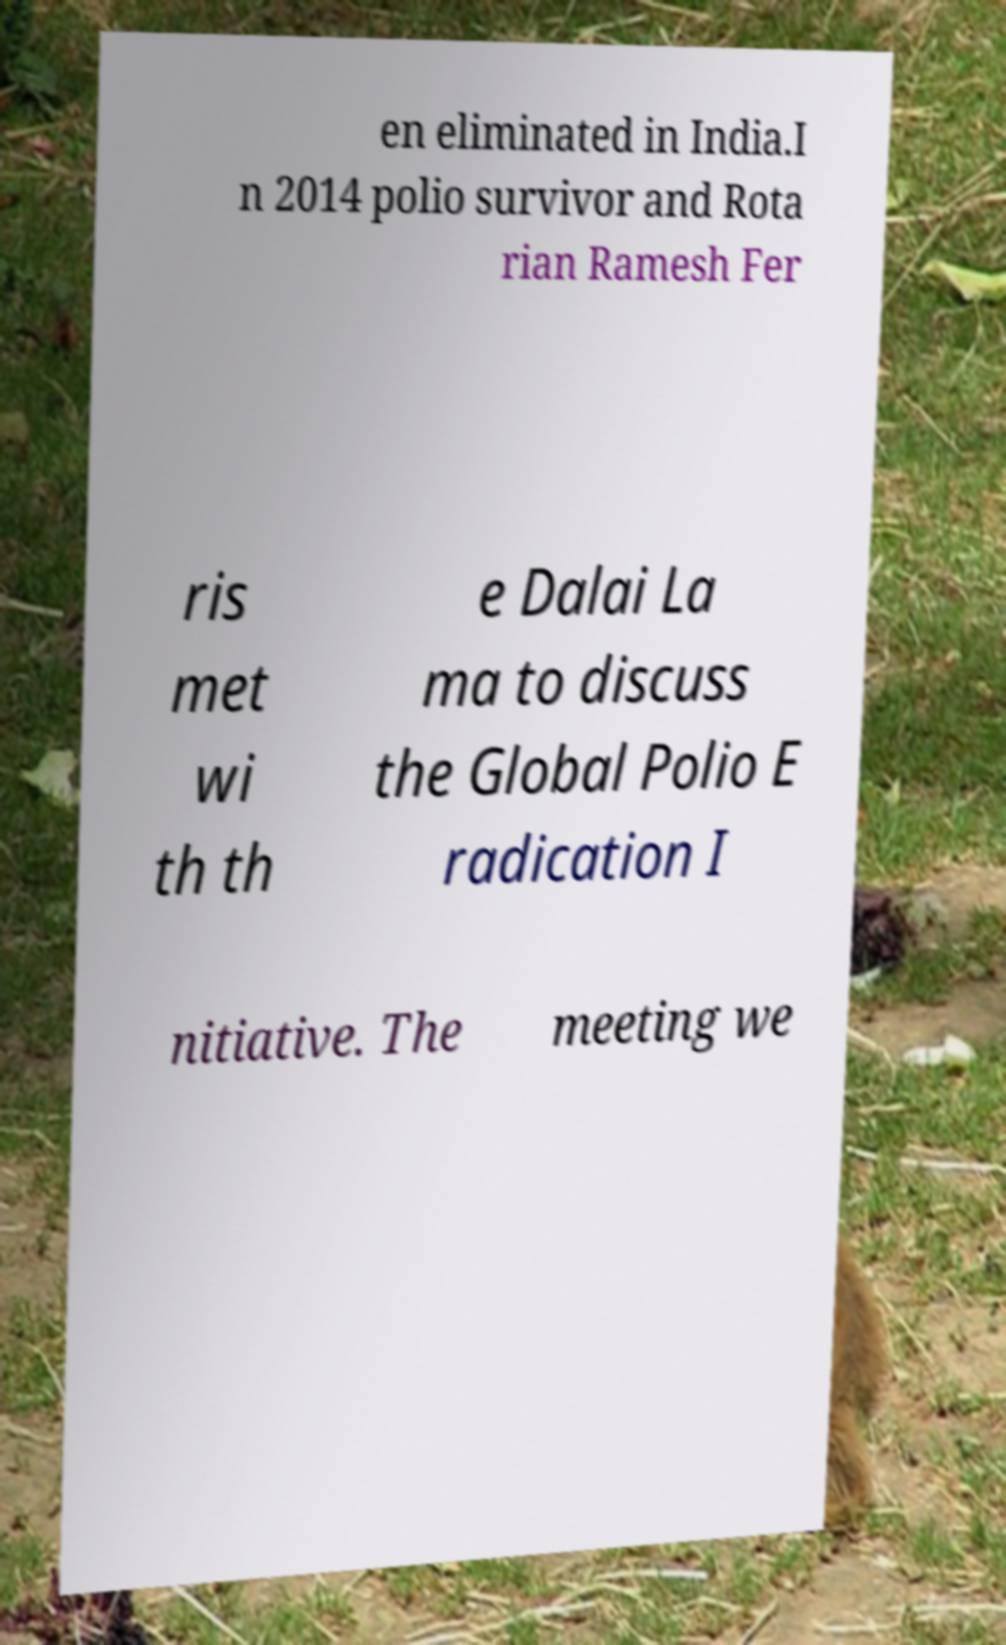There's text embedded in this image that I need extracted. Can you transcribe it verbatim? en eliminated in India.I n 2014 polio survivor and Rota rian Ramesh Fer ris met wi th th e Dalai La ma to discuss the Global Polio E radication I nitiative. The meeting we 